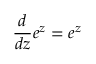<formula> <loc_0><loc_0><loc_500><loc_500>{ \frac { d } { d z } } e ^ { z } = e ^ { z }</formula> 